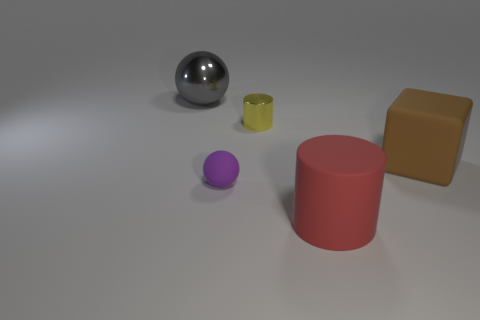Add 4 large brown balls. How many objects exist? 9 Subtract all blocks. How many objects are left? 4 Add 3 tiny green cylinders. How many tiny green cylinders exist? 3 Subtract 0 cyan cylinders. How many objects are left? 5 Subtract all green cylinders. Subtract all metallic cylinders. How many objects are left? 4 Add 5 brown blocks. How many brown blocks are left? 6 